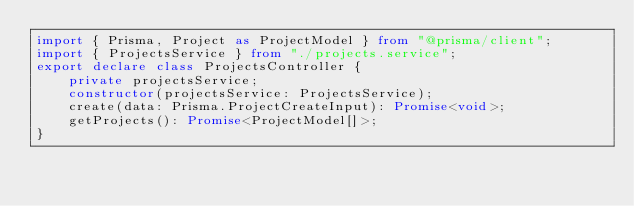Convert code to text. <code><loc_0><loc_0><loc_500><loc_500><_TypeScript_>import { Prisma, Project as ProjectModel } from "@prisma/client";
import { ProjectsService } from "./projects.service";
export declare class ProjectsController {
    private projectsService;
    constructor(projectsService: ProjectsService);
    create(data: Prisma.ProjectCreateInput): Promise<void>;
    getProjects(): Promise<ProjectModel[]>;
}
</code> 